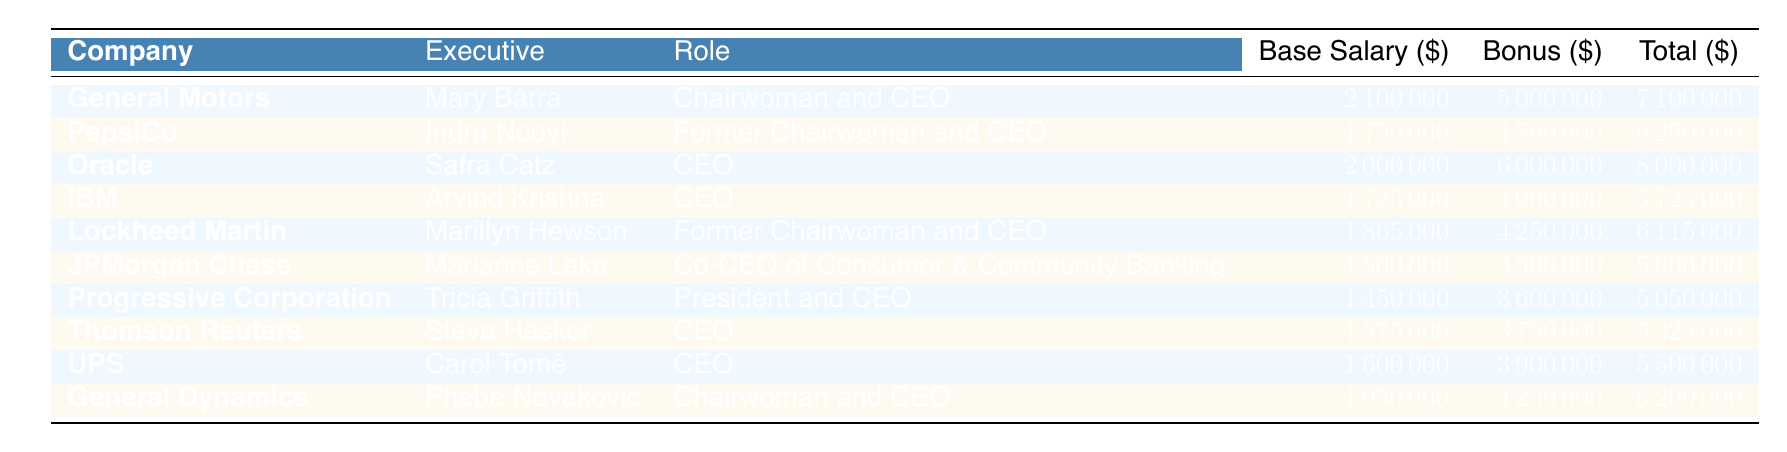What is the total compensation for Mary Barra? Mary Barra's total compensation can be found in the table under the "Total" column for General Motors. The value listed is 7,100,000.
Answer: 7,100,000 Who has the highest bonus among the executives listed? To find the highest bonus, we look at the "Bonus" column for each executive. Safra Catz has the highest bonus listed at 6,000,000 for Oracle.
Answer: Safra Catz What is the average base salary of the listed executives? First, we sum the base salaries: (2,100,000 + 1,750,000 + 2,000,000 + 1,725,000 + 1,865,000 + 1,500,000 + 1,450,000 + 1,575,000 + 1,600,000 + 1,950,000) = 19,415,000. Then, we divide by the number of executives, which is 10. The average base salary is 19,415,000 / 10 = 1,941,500.
Answer: 1,941,500 Is there any executive who has a total compensation greater than 6 million? We can check the "Total" column for each executive. General Motors, Oracle, and PepsiCo all have total compensations above 6 million. Thus, the answer is yes.
Answer: Yes What is the difference between the total compensation of Indra Nooyi and Carol Tomé? First, we find Indra Nooyi's total compensation which is 6,250,000 and Carol Tomé's at 5,500,000. We then subtract: 6,250,000 - 5,500,000 = 750,000. This gives us the difference in total compensation between the two executives.
Answer: 750,000 How many executives are former chairwomen and CEOs? We look through the "Role" column and count the instances of "Former Chairwoman and CEO." There are two: Indra Nooyi and Marillyn Hewson.
Answer: 2 Which company has the lowest base salary among the executives listed? We examine the "Base Salary" column for the smallest value. Tricia Griffith from Progressive Corporation has the lowest base salary at 1,450,000.
Answer: Progressive Corporation What is the total of all bonuses given to the executives? We can find this by summing the bonuses for each executive: (5,000,000 + 4,500,000 + 6,000,000 + 4,000,000 + 4,250,000 + 3,500,000 + 3,600,000 + 3,750,000 + 3,900,000 + 4,250,000) = 45,700,000. Thus, the total of all bonuses is 45,700,000.
Answer: 45,700,000 